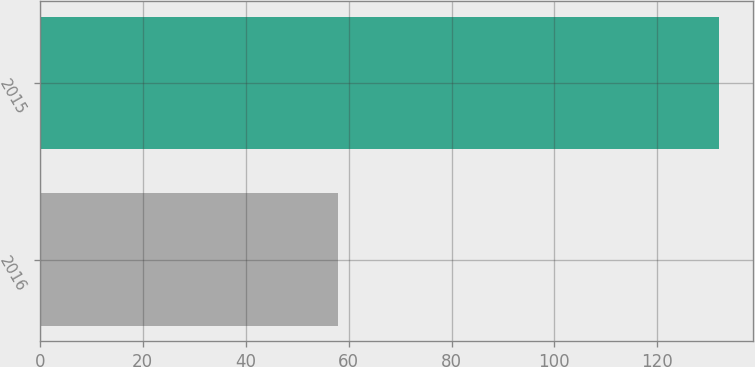<chart> <loc_0><loc_0><loc_500><loc_500><bar_chart><fcel>2016<fcel>2015<nl><fcel>58<fcel>132<nl></chart> 